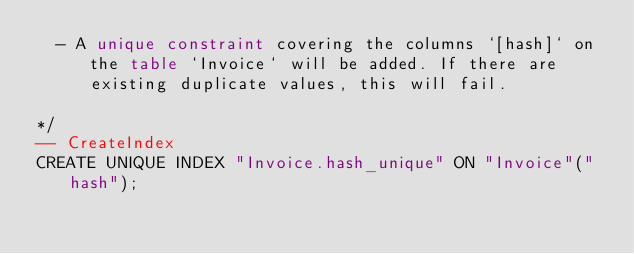Convert code to text. <code><loc_0><loc_0><loc_500><loc_500><_SQL_>  - A unique constraint covering the columns `[hash]` on the table `Invoice` will be added. If there are existing duplicate values, this will fail.

*/
-- CreateIndex
CREATE UNIQUE INDEX "Invoice.hash_unique" ON "Invoice"("hash");</code> 